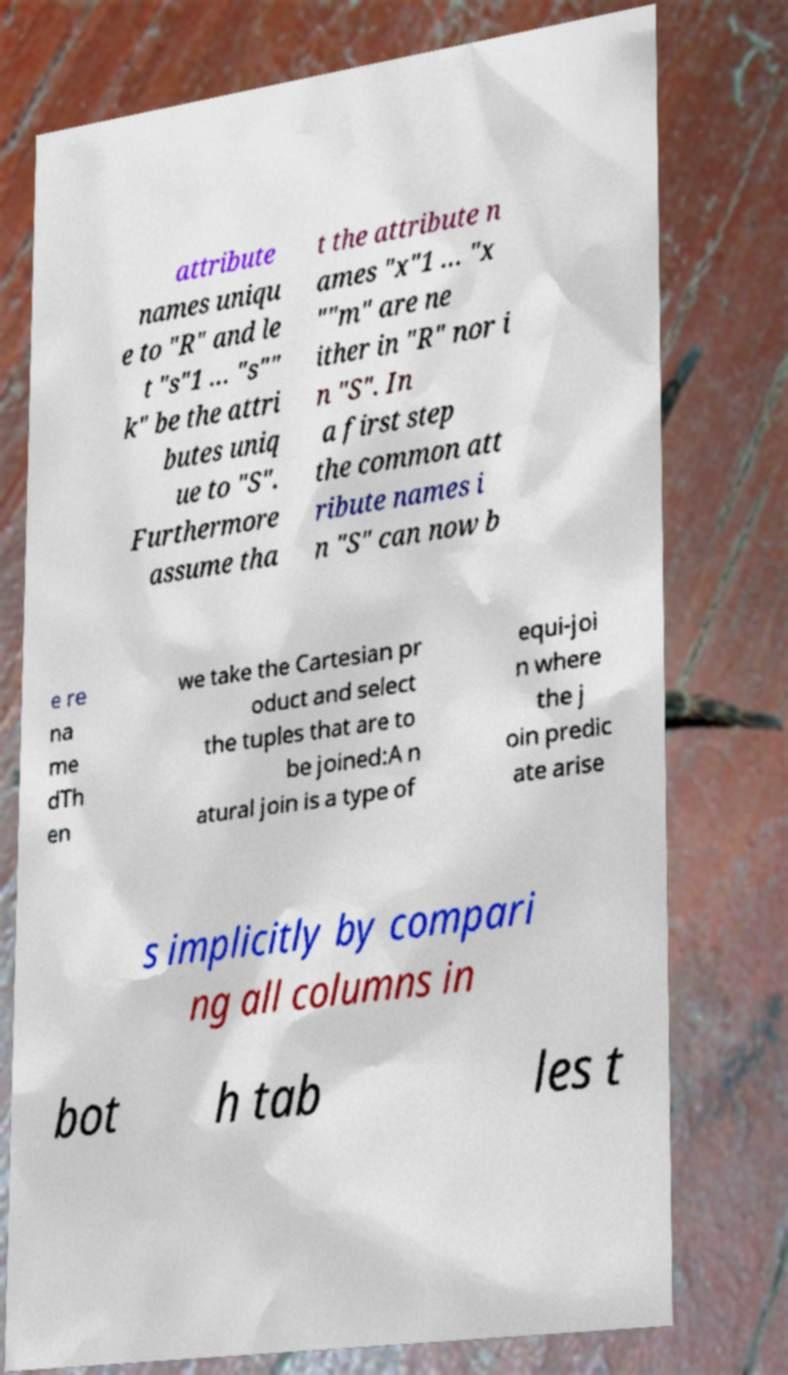What messages or text are displayed in this image? I need them in a readable, typed format. attribute names uniqu e to "R" and le t "s"1 … "s"" k" be the attri butes uniq ue to "S". Furthermore assume tha t the attribute n ames "x"1 … "x ""m" are ne ither in "R" nor i n "S". In a first step the common att ribute names i n "S" can now b e re na me dTh en we take the Cartesian pr oduct and select the tuples that are to be joined:A n atural join is a type of equi-joi n where the j oin predic ate arise s implicitly by compari ng all columns in bot h tab les t 